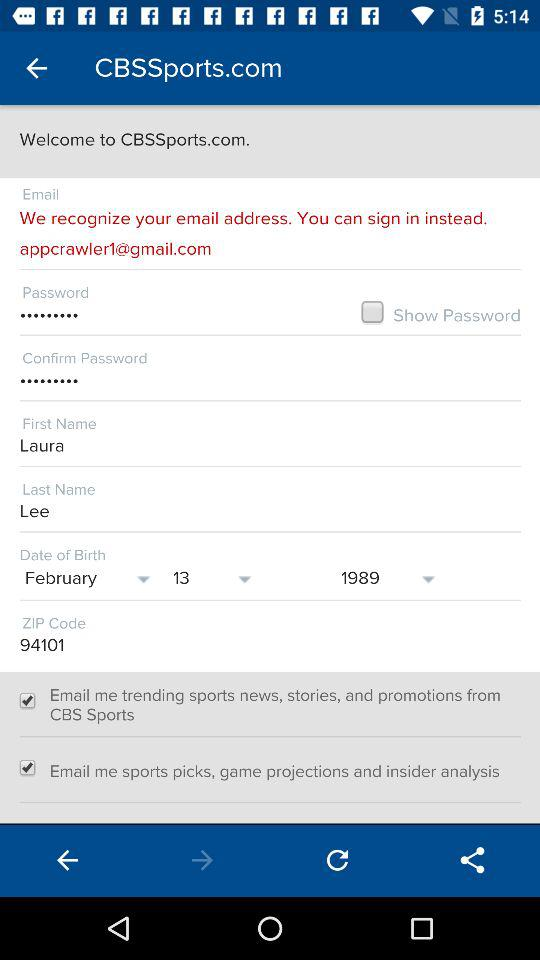What is the email address?
Answer the question using a single word or phrase. The email address is appcrawler1@gmail.com 